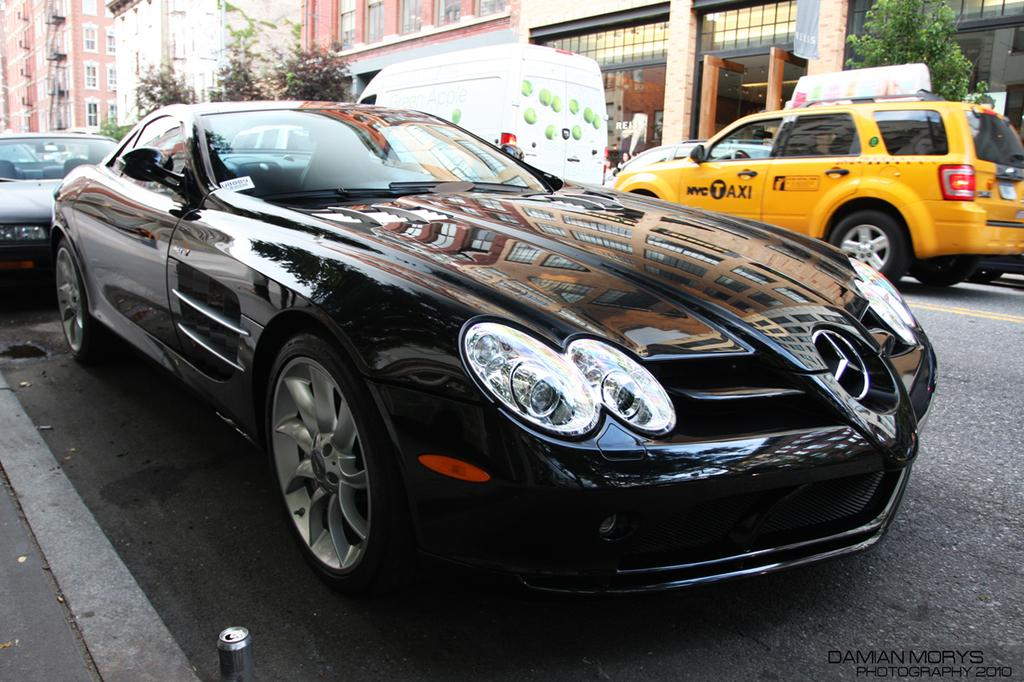What type of vehicles can be seen on the road in the image? There are cars on the road in the image. What can be seen in the background of the image? There are trees and buildings in the background of the image. What type of sock is the judge wearing in the image? There is no judge or sock present in the image. What type of plant is growing near the buildings in the image? The provided facts do not mention any plants near the buildings, so we cannot answer this question definitively. 